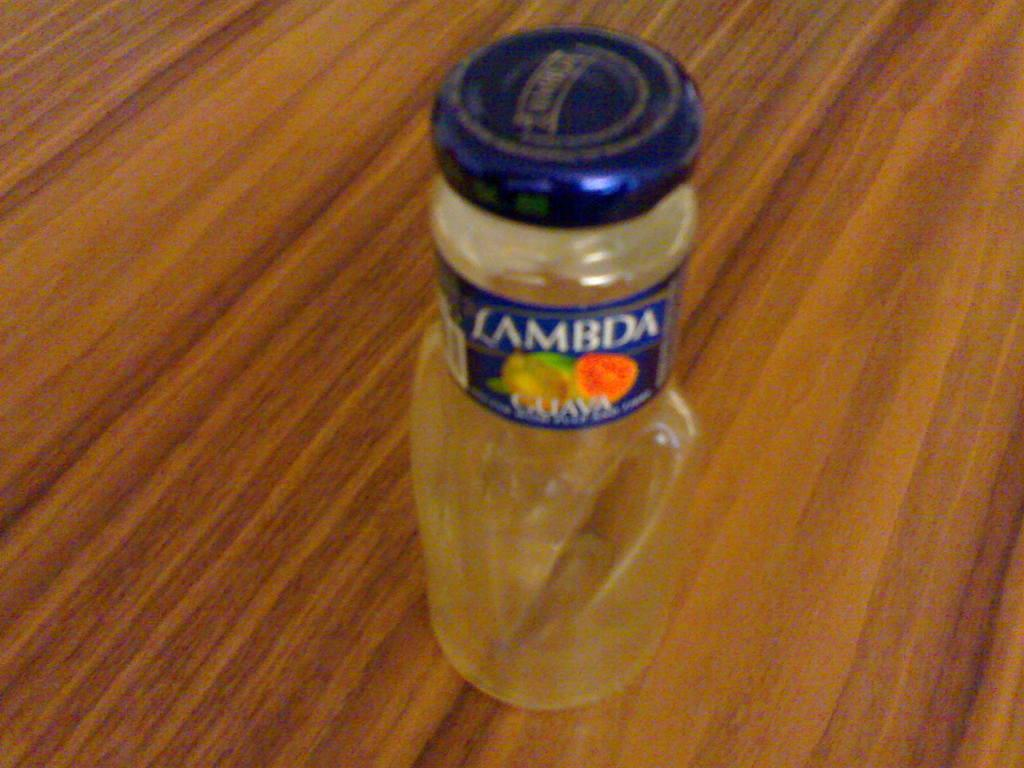What object can be seen in the image? There is a bottle in the image. What type of surface is at the bottom of the image? There is a wooden surface at the bottom of the image. How many visitors are present in the image? There is no indication of any visitors in the image. What type of pail is visible in the image? There is no pail present in the image. 